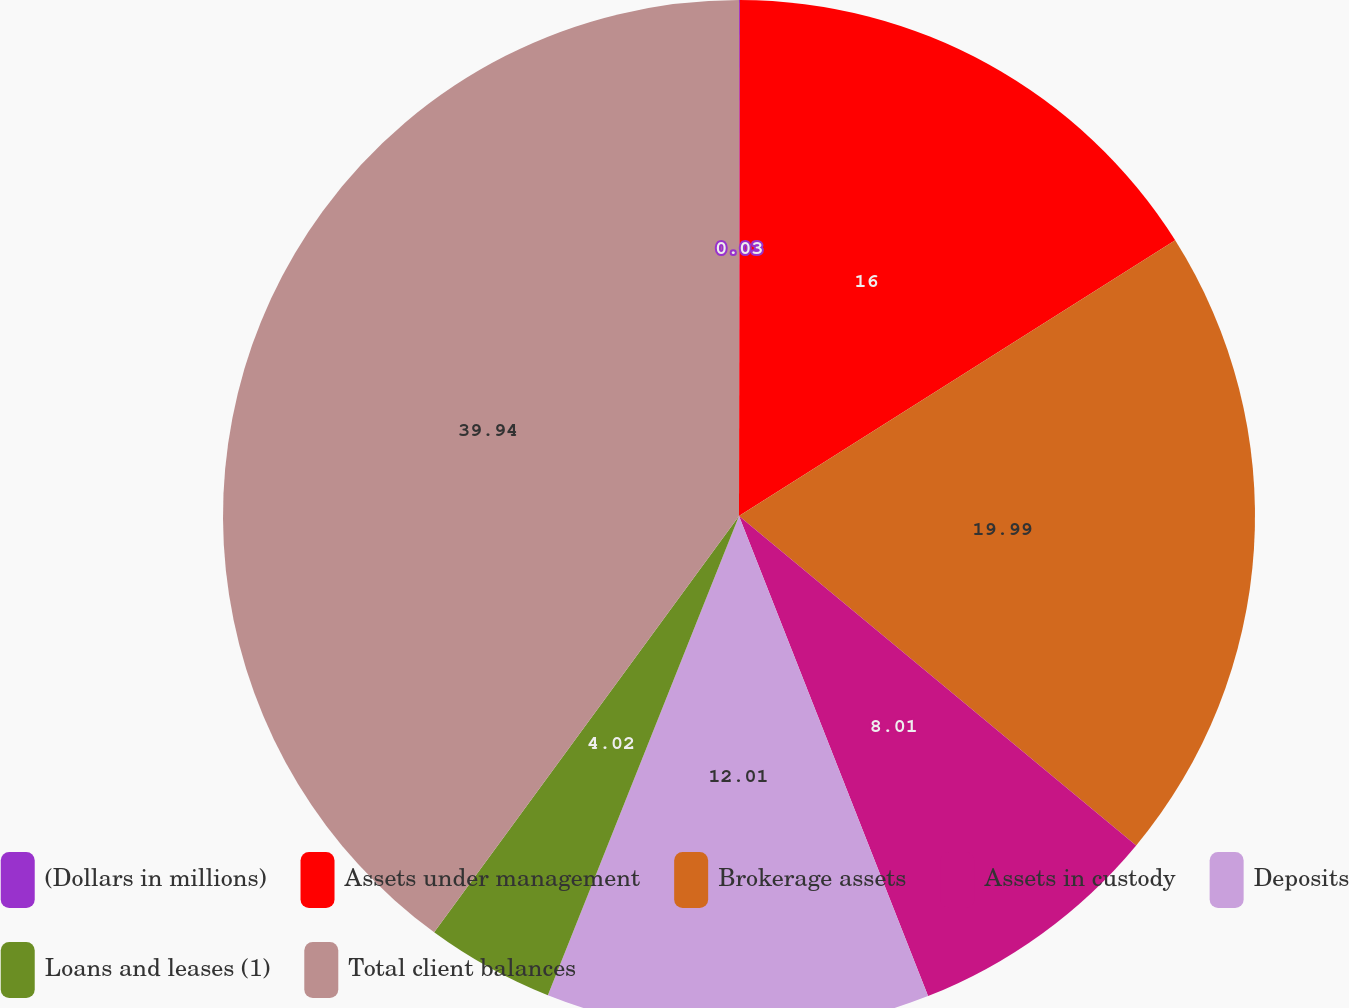Convert chart. <chart><loc_0><loc_0><loc_500><loc_500><pie_chart><fcel>(Dollars in millions)<fcel>Assets under management<fcel>Brokerage assets<fcel>Assets in custody<fcel>Deposits<fcel>Loans and leases (1)<fcel>Total client balances<nl><fcel>0.03%<fcel>16.0%<fcel>19.99%<fcel>8.01%<fcel>12.01%<fcel>4.02%<fcel>39.94%<nl></chart> 